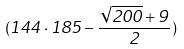<formula> <loc_0><loc_0><loc_500><loc_500>( 1 4 4 \cdot 1 8 5 - \frac { \sqrt { 2 0 0 } + 9 } { 2 } )</formula> 